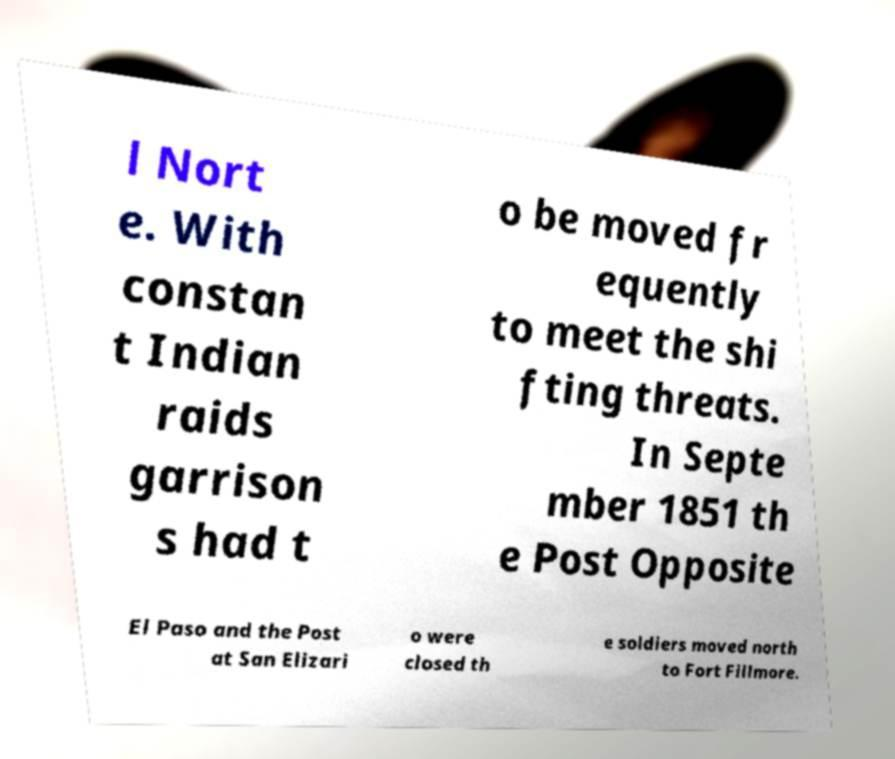There's text embedded in this image that I need extracted. Can you transcribe it verbatim? l Nort e. With constan t Indian raids garrison s had t o be moved fr equently to meet the shi fting threats. In Septe mber 1851 th e Post Opposite El Paso and the Post at San Elizari o were closed th e soldiers moved north to Fort Fillmore. 